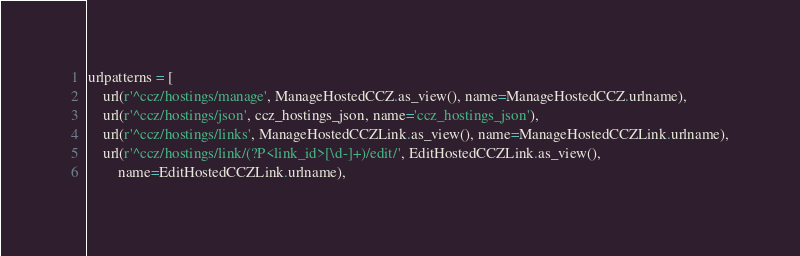<code> <loc_0><loc_0><loc_500><loc_500><_Python_>
urlpatterns = [
    url(r'^ccz/hostings/manage', ManageHostedCCZ.as_view(), name=ManageHostedCCZ.urlname),
    url(r'^ccz/hostings/json', ccz_hostings_json, name='ccz_hostings_json'),
    url(r'^ccz/hostings/links', ManageHostedCCZLink.as_view(), name=ManageHostedCCZLink.urlname),
    url(r'^ccz/hostings/link/(?P<link_id>[\d-]+)/edit/', EditHostedCCZLink.as_view(),
        name=EditHostedCCZLink.urlname),</code> 